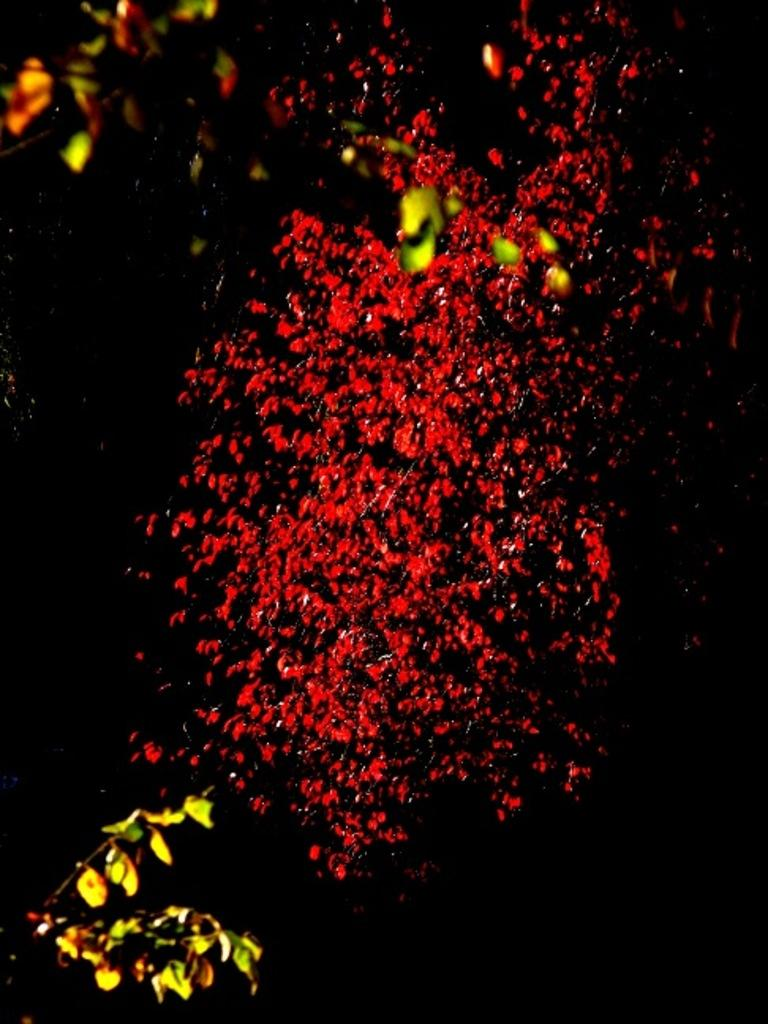What type of natural elements can be seen in the image? There are tree branches in the image. Are there any specific colors associated with the flowers in the image? There may be red flowers visible in the image. How would you describe the overall lighting or brightness of the image? The background of the image is dark. Can you tell me how many records are stacked on the tree branches in the image? There are no records present in the image; it features tree branches and possibly red flowers. What type of jewel is hanging from the tree branches in the image? There are no jewels present in the image; it features tree branches and possibly red flowers. 